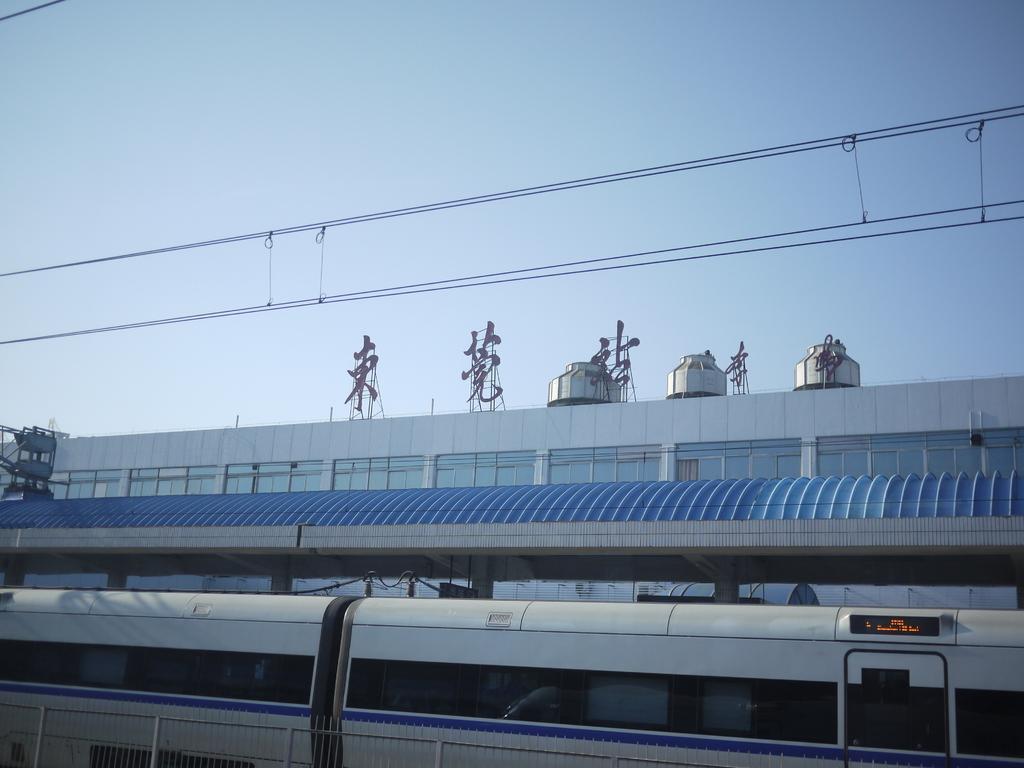Can you describe this image briefly? In this image there is a train. Behind the train there is a shed. In front of the train there is a railing. In the background there are buildings. There are objects on the buildings. At the top there is the sky. 